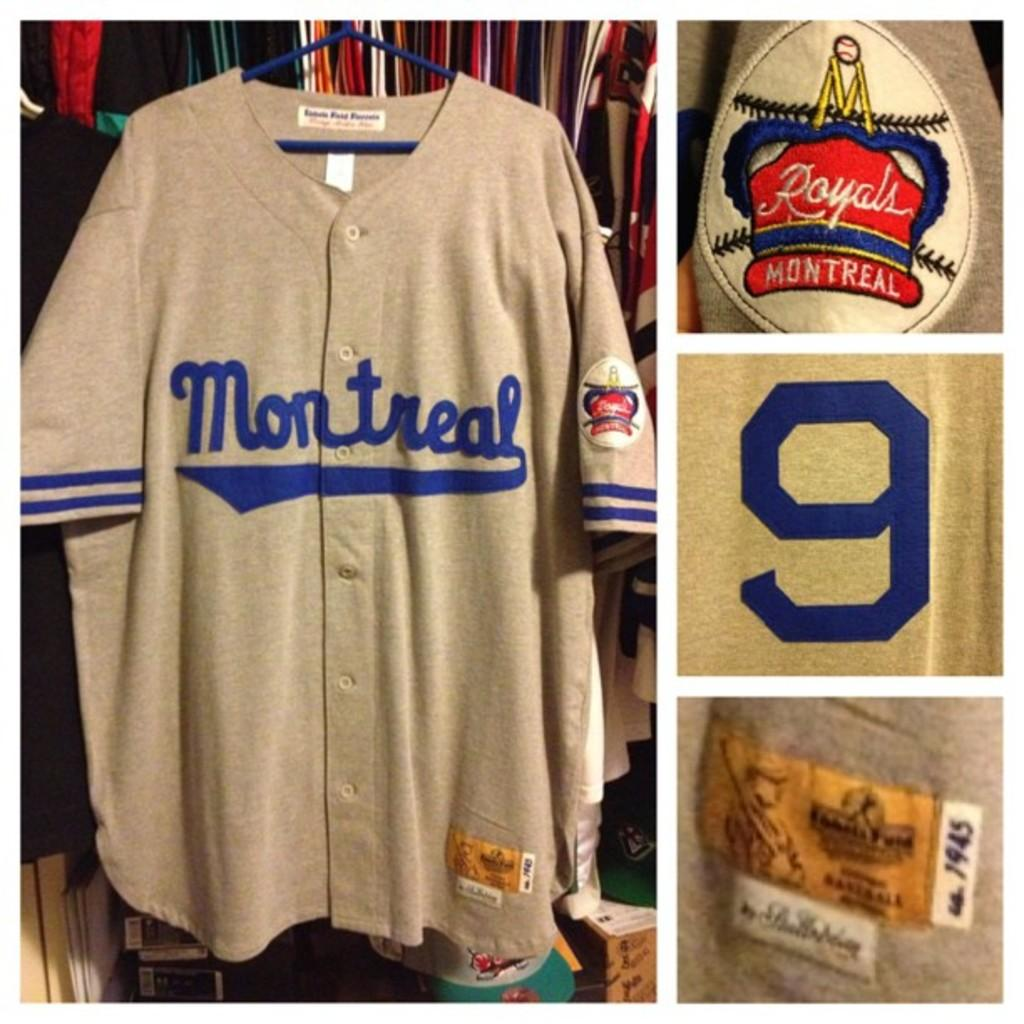<image>
Relay a brief, clear account of the picture shown. A grey jersey is hanging up that says Montreal in blue letters and there is also a baseball cap that says Royal Montreal in white with a red background. 